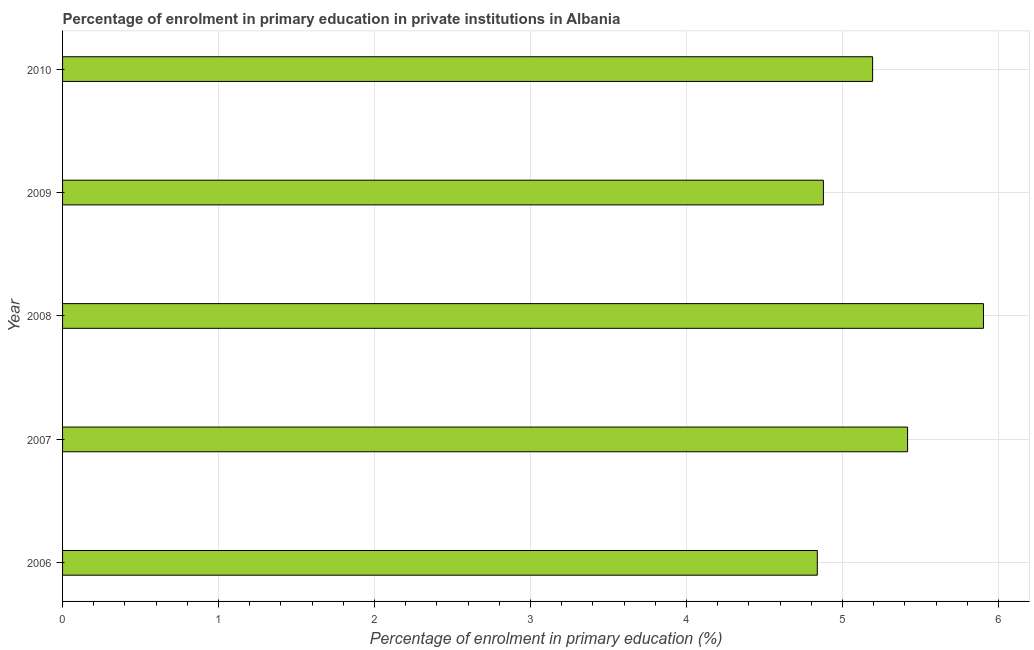What is the title of the graph?
Keep it short and to the point. Percentage of enrolment in primary education in private institutions in Albania. What is the label or title of the X-axis?
Offer a very short reply. Percentage of enrolment in primary education (%). What is the label or title of the Y-axis?
Your answer should be very brief. Year. What is the enrolment percentage in primary education in 2010?
Offer a terse response. 5.19. Across all years, what is the maximum enrolment percentage in primary education?
Provide a succinct answer. 5.9. Across all years, what is the minimum enrolment percentage in primary education?
Make the answer very short. 4.84. What is the sum of the enrolment percentage in primary education?
Make the answer very short. 26.23. What is the average enrolment percentage in primary education per year?
Your answer should be compact. 5.25. What is the median enrolment percentage in primary education?
Keep it short and to the point. 5.19. In how many years, is the enrolment percentage in primary education greater than 3.8 %?
Provide a succinct answer. 5. Do a majority of the years between 2006 and 2007 (inclusive) have enrolment percentage in primary education greater than 1 %?
Provide a succinct answer. Yes. What is the ratio of the enrolment percentage in primary education in 2006 to that in 2010?
Ensure brevity in your answer.  0.93. What is the difference between the highest and the second highest enrolment percentage in primary education?
Keep it short and to the point. 0.49. What is the difference between the highest and the lowest enrolment percentage in primary education?
Your response must be concise. 1.07. In how many years, is the enrolment percentage in primary education greater than the average enrolment percentage in primary education taken over all years?
Ensure brevity in your answer.  2. How many years are there in the graph?
Give a very brief answer. 5. What is the difference between two consecutive major ticks on the X-axis?
Keep it short and to the point. 1. What is the Percentage of enrolment in primary education (%) in 2006?
Offer a very short reply. 4.84. What is the Percentage of enrolment in primary education (%) of 2007?
Your response must be concise. 5.42. What is the Percentage of enrolment in primary education (%) in 2008?
Your response must be concise. 5.9. What is the Percentage of enrolment in primary education (%) of 2009?
Keep it short and to the point. 4.88. What is the Percentage of enrolment in primary education (%) of 2010?
Your answer should be compact. 5.19. What is the difference between the Percentage of enrolment in primary education (%) in 2006 and 2007?
Provide a short and direct response. -0.58. What is the difference between the Percentage of enrolment in primary education (%) in 2006 and 2008?
Your answer should be compact. -1.07. What is the difference between the Percentage of enrolment in primary education (%) in 2006 and 2009?
Provide a short and direct response. -0.04. What is the difference between the Percentage of enrolment in primary education (%) in 2006 and 2010?
Your answer should be very brief. -0.35. What is the difference between the Percentage of enrolment in primary education (%) in 2007 and 2008?
Your answer should be compact. -0.49. What is the difference between the Percentage of enrolment in primary education (%) in 2007 and 2009?
Keep it short and to the point. 0.54. What is the difference between the Percentage of enrolment in primary education (%) in 2007 and 2010?
Make the answer very short. 0.22. What is the difference between the Percentage of enrolment in primary education (%) in 2008 and 2009?
Give a very brief answer. 1.03. What is the difference between the Percentage of enrolment in primary education (%) in 2008 and 2010?
Make the answer very short. 0.71. What is the difference between the Percentage of enrolment in primary education (%) in 2009 and 2010?
Your answer should be very brief. -0.32. What is the ratio of the Percentage of enrolment in primary education (%) in 2006 to that in 2007?
Your answer should be compact. 0.89. What is the ratio of the Percentage of enrolment in primary education (%) in 2006 to that in 2008?
Give a very brief answer. 0.82. What is the ratio of the Percentage of enrolment in primary education (%) in 2006 to that in 2009?
Ensure brevity in your answer.  0.99. What is the ratio of the Percentage of enrolment in primary education (%) in 2006 to that in 2010?
Ensure brevity in your answer.  0.93. What is the ratio of the Percentage of enrolment in primary education (%) in 2007 to that in 2008?
Provide a short and direct response. 0.92. What is the ratio of the Percentage of enrolment in primary education (%) in 2007 to that in 2009?
Offer a terse response. 1.11. What is the ratio of the Percentage of enrolment in primary education (%) in 2007 to that in 2010?
Your response must be concise. 1.04. What is the ratio of the Percentage of enrolment in primary education (%) in 2008 to that in 2009?
Your answer should be compact. 1.21. What is the ratio of the Percentage of enrolment in primary education (%) in 2008 to that in 2010?
Offer a very short reply. 1.14. What is the ratio of the Percentage of enrolment in primary education (%) in 2009 to that in 2010?
Your answer should be very brief. 0.94. 